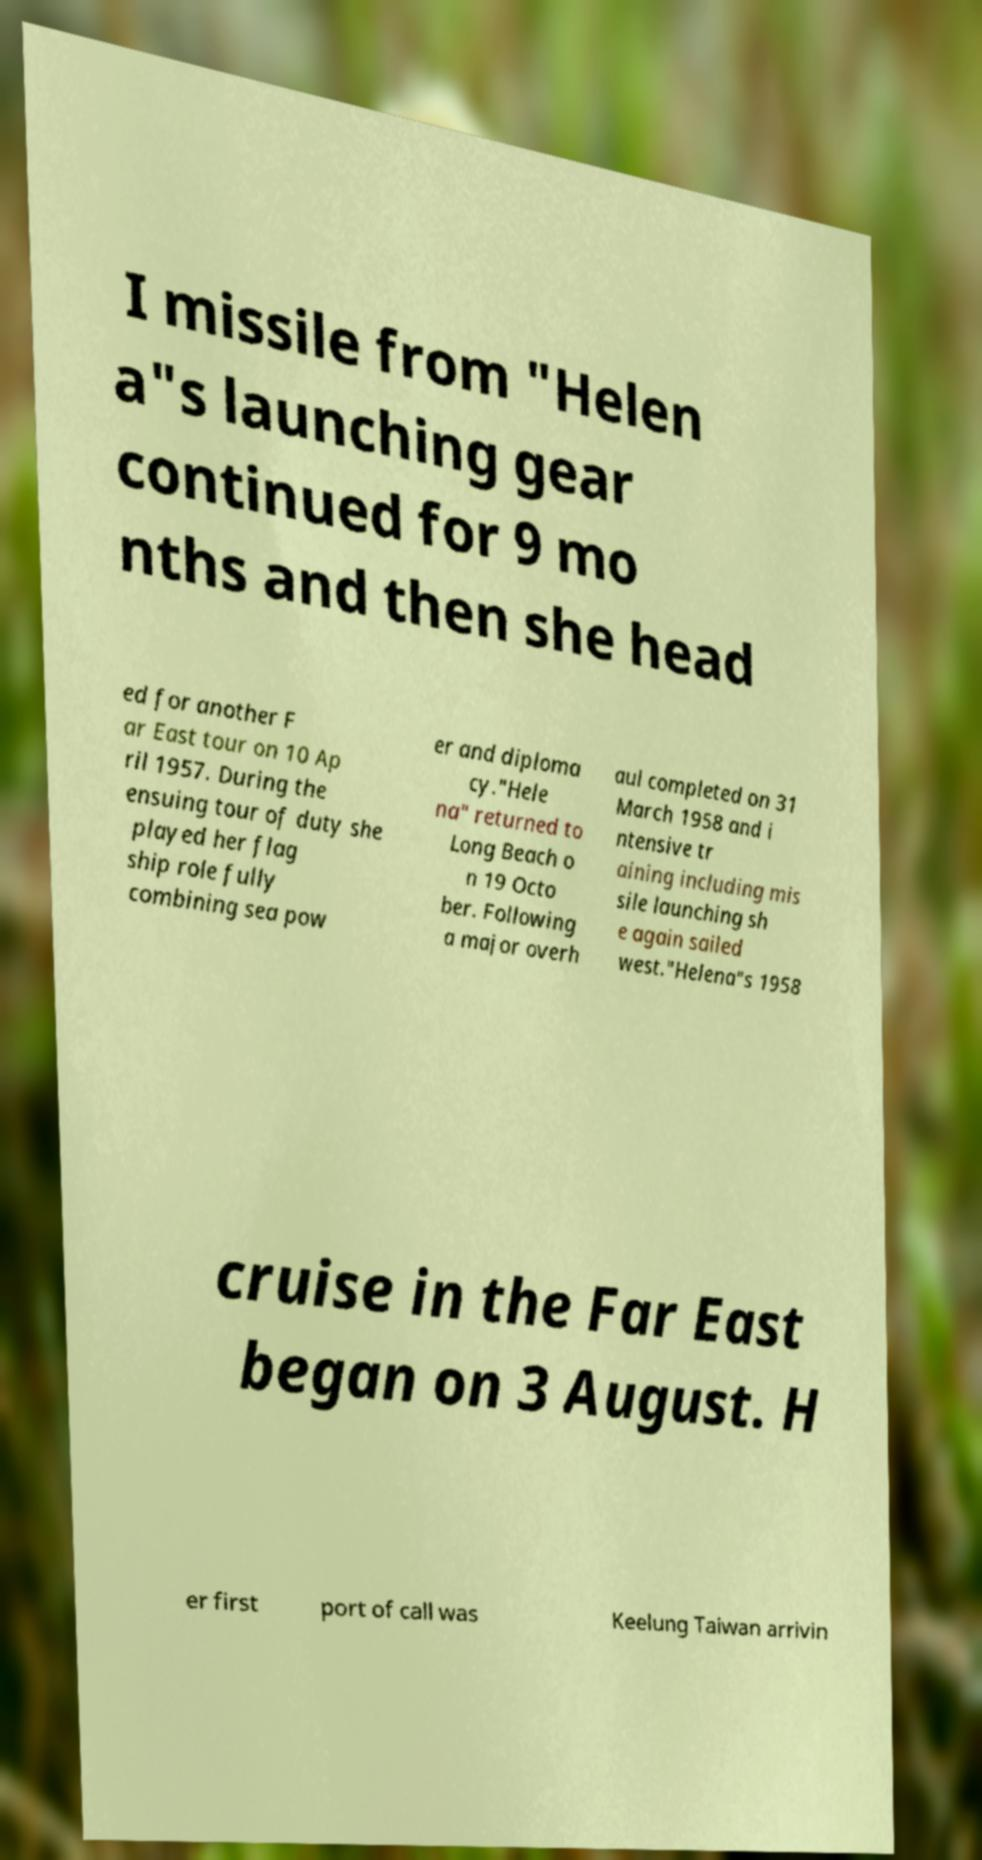For documentation purposes, I need the text within this image transcribed. Could you provide that? I missile from "Helen a"s launching gear continued for 9 mo nths and then she head ed for another F ar East tour on 10 Ap ril 1957. During the ensuing tour of duty she played her flag ship role fully combining sea pow er and diploma cy."Hele na" returned to Long Beach o n 19 Octo ber. Following a major overh aul completed on 31 March 1958 and i ntensive tr aining including mis sile launching sh e again sailed west."Helena"s 1958 cruise in the Far East began on 3 August. H er first port of call was Keelung Taiwan arrivin 